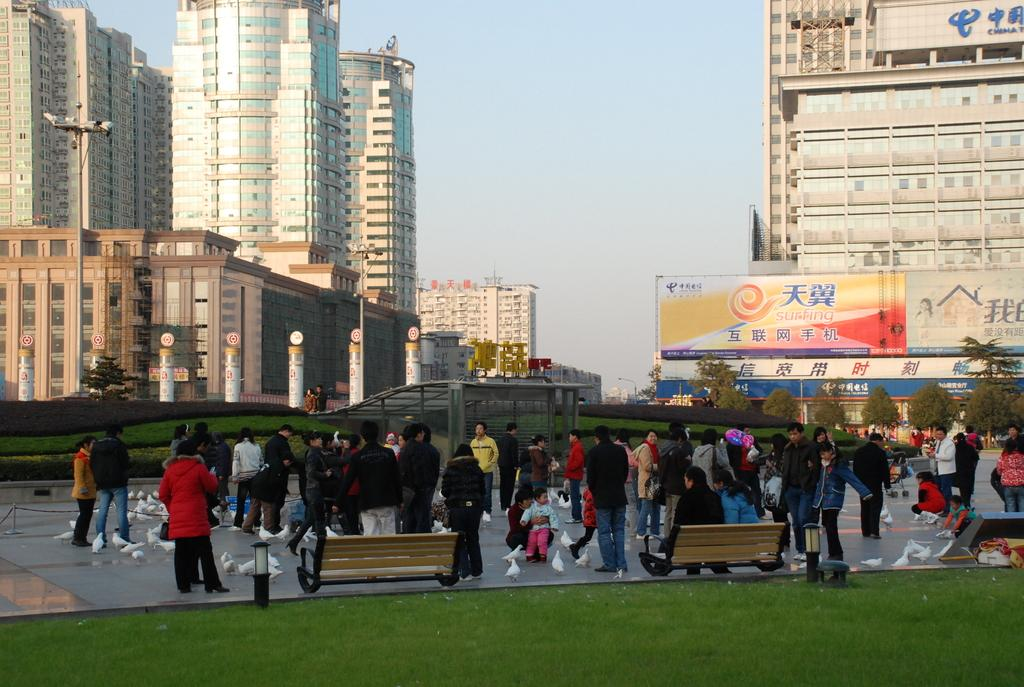What is happening in the image? There is a group of people standing in the image. What can be seen in the background of the image? There are light poles, buildings, boards, and trees with green color in the background of the image. What is the color of the sky in the image? The sky is blue and white in color. Is there an umbrella being used for approval on a table in the image? No, there is no umbrella or table present in the image. 